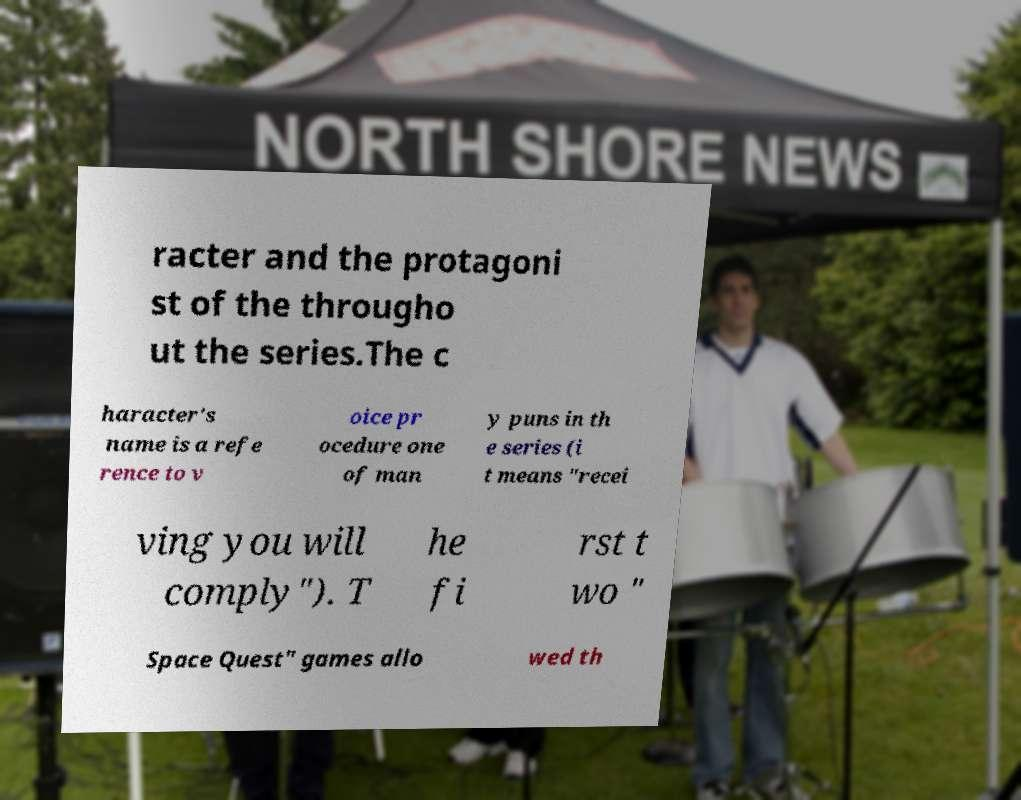For documentation purposes, I need the text within this image transcribed. Could you provide that? racter and the protagoni st of the througho ut the series.The c haracter's name is a refe rence to v oice pr ocedure one of man y puns in th e series (i t means "recei ving you will comply"). T he fi rst t wo " Space Quest" games allo wed th 